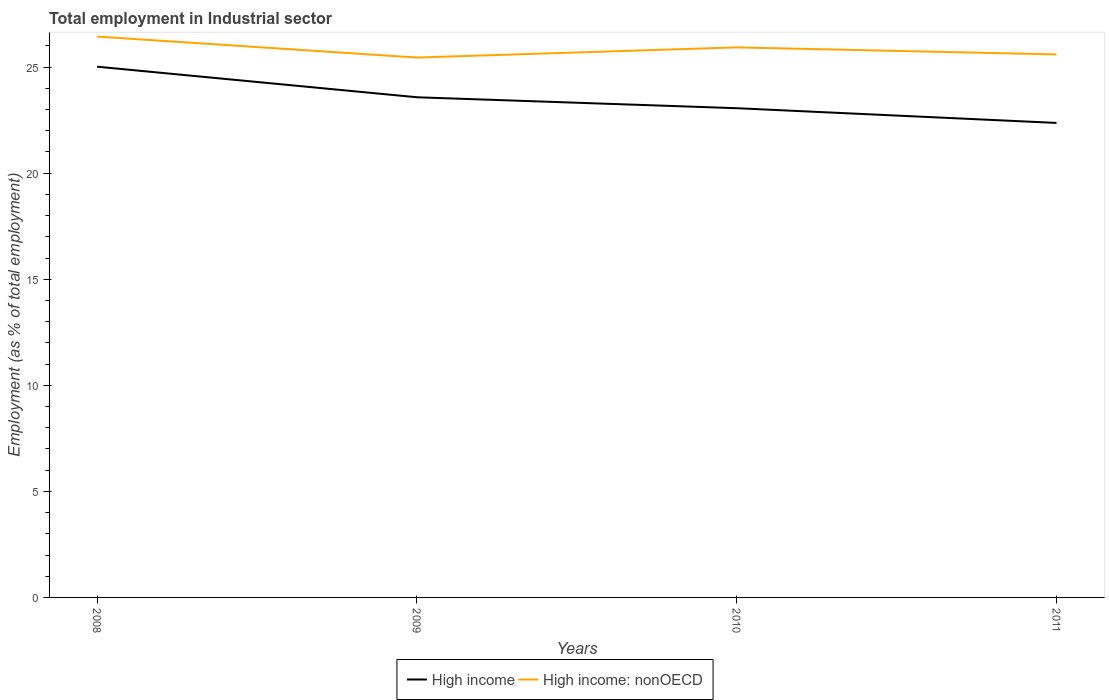How many different coloured lines are there?
Your answer should be compact. 2. Across all years, what is the maximum employment in industrial sector in High income: nonOECD?
Your answer should be compact. 25.45. In which year was the employment in industrial sector in High income: nonOECD maximum?
Ensure brevity in your answer.  2009. What is the total employment in industrial sector in High income: nonOECD in the graph?
Give a very brief answer. 0.99. What is the difference between the highest and the second highest employment in industrial sector in High income?
Offer a terse response. 2.65. What is the difference between the highest and the lowest employment in industrial sector in High income: nonOECD?
Provide a short and direct response. 2. Is the employment in industrial sector in High income: nonOECD strictly greater than the employment in industrial sector in High income over the years?
Make the answer very short. No. How many years are there in the graph?
Your answer should be very brief. 4. What is the difference between two consecutive major ticks on the Y-axis?
Your response must be concise. 5. Does the graph contain grids?
Your response must be concise. No. How are the legend labels stacked?
Give a very brief answer. Horizontal. What is the title of the graph?
Your response must be concise. Total employment in Industrial sector. What is the label or title of the Y-axis?
Ensure brevity in your answer.  Employment (as % of total employment). What is the Employment (as % of total employment) in High income in 2008?
Provide a short and direct response. 25.02. What is the Employment (as % of total employment) in High income: nonOECD in 2008?
Give a very brief answer. 26.44. What is the Employment (as % of total employment) in High income in 2009?
Keep it short and to the point. 23.58. What is the Employment (as % of total employment) in High income: nonOECD in 2009?
Offer a very short reply. 25.45. What is the Employment (as % of total employment) of High income in 2010?
Give a very brief answer. 23.06. What is the Employment (as % of total employment) of High income: nonOECD in 2010?
Your answer should be very brief. 25.93. What is the Employment (as % of total employment) in High income in 2011?
Offer a terse response. 22.37. What is the Employment (as % of total employment) in High income: nonOECD in 2011?
Offer a very short reply. 25.6. Across all years, what is the maximum Employment (as % of total employment) of High income?
Provide a short and direct response. 25.02. Across all years, what is the maximum Employment (as % of total employment) of High income: nonOECD?
Provide a short and direct response. 26.44. Across all years, what is the minimum Employment (as % of total employment) in High income?
Your answer should be compact. 22.37. Across all years, what is the minimum Employment (as % of total employment) in High income: nonOECD?
Your response must be concise. 25.45. What is the total Employment (as % of total employment) of High income in the graph?
Keep it short and to the point. 94.04. What is the total Employment (as % of total employment) in High income: nonOECD in the graph?
Keep it short and to the point. 103.42. What is the difference between the Employment (as % of total employment) in High income in 2008 and that in 2009?
Ensure brevity in your answer.  1.44. What is the difference between the Employment (as % of total employment) of High income: nonOECD in 2008 and that in 2009?
Offer a terse response. 0.99. What is the difference between the Employment (as % of total employment) of High income in 2008 and that in 2010?
Provide a succinct answer. 1.96. What is the difference between the Employment (as % of total employment) of High income: nonOECD in 2008 and that in 2010?
Provide a succinct answer. 0.51. What is the difference between the Employment (as % of total employment) of High income in 2008 and that in 2011?
Provide a succinct answer. 2.65. What is the difference between the Employment (as % of total employment) of High income: nonOECD in 2008 and that in 2011?
Offer a terse response. 0.84. What is the difference between the Employment (as % of total employment) of High income in 2009 and that in 2010?
Ensure brevity in your answer.  0.52. What is the difference between the Employment (as % of total employment) in High income: nonOECD in 2009 and that in 2010?
Your response must be concise. -0.48. What is the difference between the Employment (as % of total employment) in High income in 2009 and that in 2011?
Make the answer very short. 1.21. What is the difference between the Employment (as % of total employment) in High income: nonOECD in 2009 and that in 2011?
Your answer should be very brief. -0.15. What is the difference between the Employment (as % of total employment) of High income in 2010 and that in 2011?
Your response must be concise. 0.69. What is the difference between the Employment (as % of total employment) of High income: nonOECD in 2010 and that in 2011?
Ensure brevity in your answer.  0.33. What is the difference between the Employment (as % of total employment) in High income in 2008 and the Employment (as % of total employment) in High income: nonOECD in 2009?
Provide a short and direct response. -0.43. What is the difference between the Employment (as % of total employment) of High income in 2008 and the Employment (as % of total employment) of High income: nonOECD in 2010?
Provide a short and direct response. -0.91. What is the difference between the Employment (as % of total employment) of High income in 2008 and the Employment (as % of total employment) of High income: nonOECD in 2011?
Keep it short and to the point. -0.58. What is the difference between the Employment (as % of total employment) of High income in 2009 and the Employment (as % of total employment) of High income: nonOECD in 2010?
Keep it short and to the point. -2.35. What is the difference between the Employment (as % of total employment) of High income in 2009 and the Employment (as % of total employment) of High income: nonOECD in 2011?
Offer a terse response. -2.02. What is the difference between the Employment (as % of total employment) in High income in 2010 and the Employment (as % of total employment) in High income: nonOECD in 2011?
Keep it short and to the point. -2.54. What is the average Employment (as % of total employment) in High income per year?
Keep it short and to the point. 23.51. What is the average Employment (as % of total employment) of High income: nonOECD per year?
Your response must be concise. 25.86. In the year 2008, what is the difference between the Employment (as % of total employment) in High income and Employment (as % of total employment) in High income: nonOECD?
Provide a succinct answer. -1.42. In the year 2009, what is the difference between the Employment (as % of total employment) in High income and Employment (as % of total employment) in High income: nonOECD?
Provide a short and direct response. -1.87. In the year 2010, what is the difference between the Employment (as % of total employment) of High income and Employment (as % of total employment) of High income: nonOECD?
Provide a short and direct response. -2.87. In the year 2011, what is the difference between the Employment (as % of total employment) of High income and Employment (as % of total employment) of High income: nonOECD?
Offer a terse response. -3.23. What is the ratio of the Employment (as % of total employment) of High income in 2008 to that in 2009?
Ensure brevity in your answer.  1.06. What is the ratio of the Employment (as % of total employment) in High income: nonOECD in 2008 to that in 2009?
Offer a terse response. 1.04. What is the ratio of the Employment (as % of total employment) in High income in 2008 to that in 2010?
Give a very brief answer. 1.08. What is the ratio of the Employment (as % of total employment) in High income: nonOECD in 2008 to that in 2010?
Offer a terse response. 1.02. What is the ratio of the Employment (as % of total employment) of High income in 2008 to that in 2011?
Ensure brevity in your answer.  1.12. What is the ratio of the Employment (as % of total employment) of High income: nonOECD in 2008 to that in 2011?
Your answer should be compact. 1.03. What is the ratio of the Employment (as % of total employment) in High income in 2009 to that in 2010?
Your answer should be compact. 1.02. What is the ratio of the Employment (as % of total employment) in High income: nonOECD in 2009 to that in 2010?
Give a very brief answer. 0.98. What is the ratio of the Employment (as % of total employment) in High income in 2009 to that in 2011?
Provide a short and direct response. 1.05. What is the ratio of the Employment (as % of total employment) in High income: nonOECD in 2009 to that in 2011?
Your answer should be compact. 0.99. What is the ratio of the Employment (as % of total employment) in High income in 2010 to that in 2011?
Give a very brief answer. 1.03. What is the ratio of the Employment (as % of total employment) in High income: nonOECD in 2010 to that in 2011?
Offer a very short reply. 1.01. What is the difference between the highest and the second highest Employment (as % of total employment) in High income?
Your answer should be very brief. 1.44. What is the difference between the highest and the second highest Employment (as % of total employment) of High income: nonOECD?
Provide a succinct answer. 0.51. What is the difference between the highest and the lowest Employment (as % of total employment) of High income?
Provide a short and direct response. 2.65. 